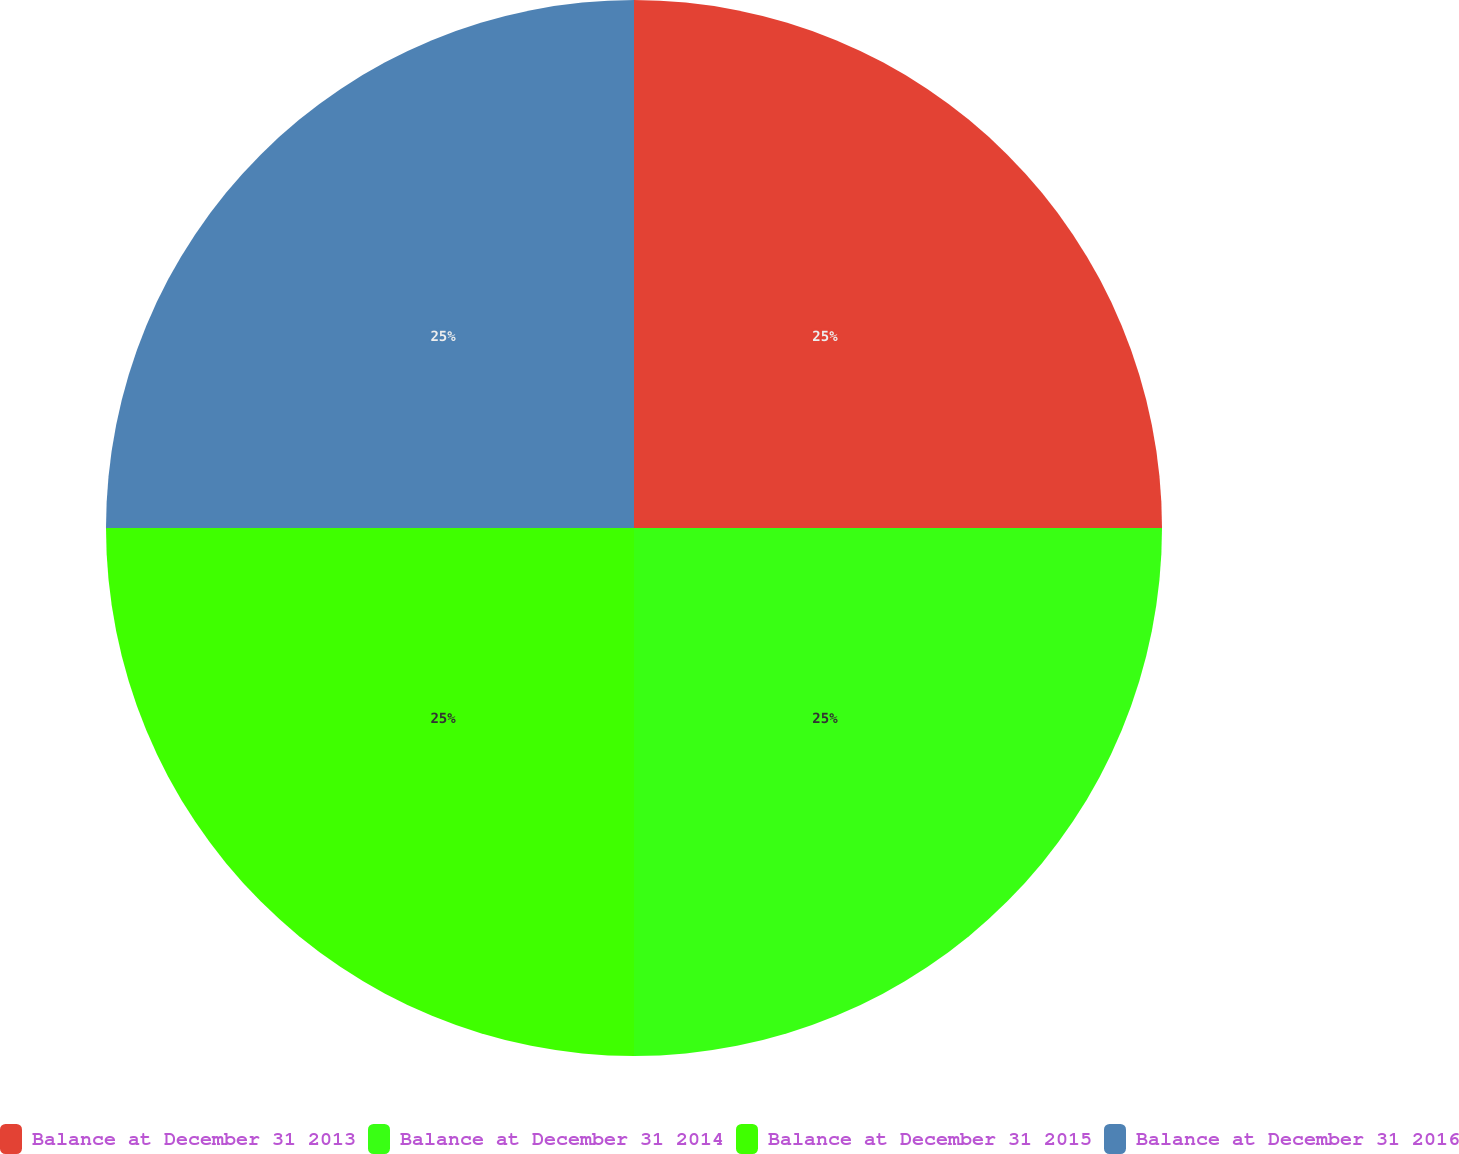Convert chart. <chart><loc_0><loc_0><loc_500><loc_500><pie_chart><fcel>Balance at December 31 2013<fcel>Balance at December 31 2014<fcel>Balance at December 31 2015<fcel>Balance at December 31 2016<nl><fcel>25.0%<fcel>25.0%<fcel>25.0%<fcel>25.0%<nl></chart> 